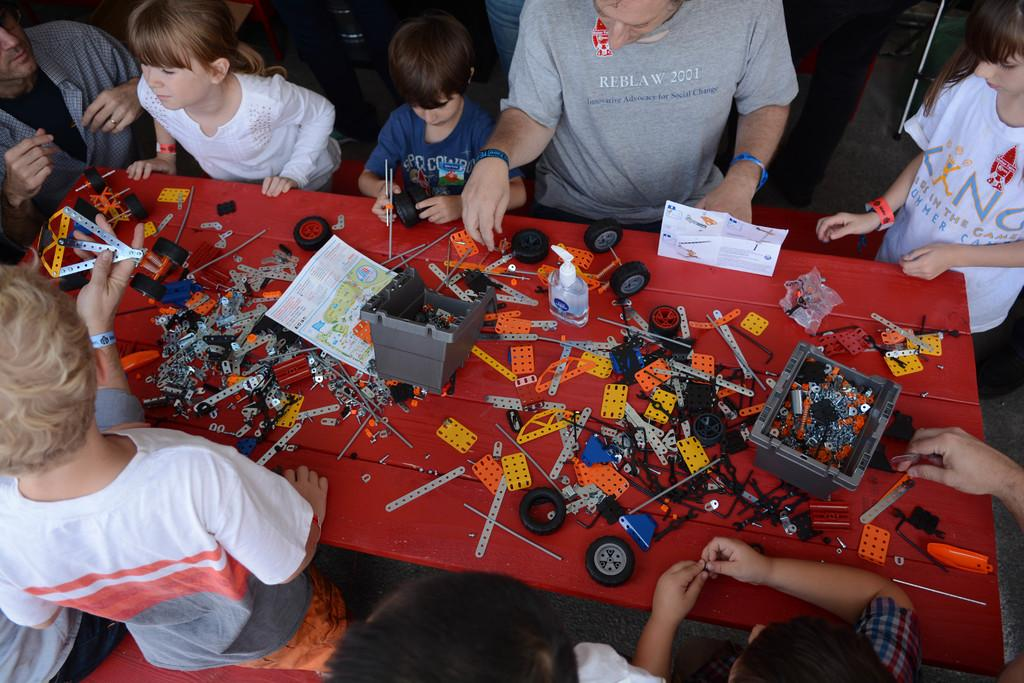What type of furniture is present in the image? There is a table in the image. What is covering the table? There is a red cloth on the table. Are there any people in the image? Yes, there are people standing around the table. What can be found on the table? There are objects on the table. What is the weight of the ear visible on the table? There is no ear present on the table in the image. 